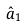Convert formula to latex. <formula><loc_0><loc_0><loc_500><loc_500>\hat { a } _ { 1 }</formula> 